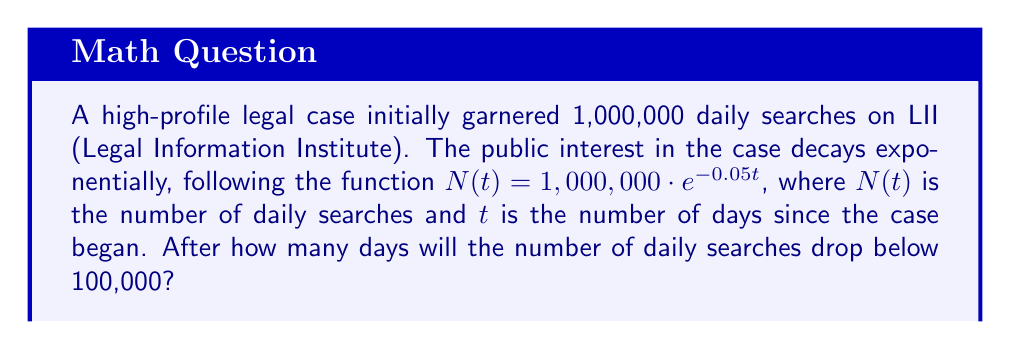Teach me how to tackle this problem. To solve this problem, we need to use the properties of logarithms. Let's approach this step-by-step:

1) We're given the function $N(t) = 1,000,000 \cdot e^{-0.05t}$

2) We want to find $t$ when $N(t) < 100,000$

3) Let's set up the equation:
   $100,000 = 1,000,000 \cdot e^{-0.05t}$

4) Divide both sides by 1,000,000:
   $0.1 = e^{-0.05t}$

5) Now, let's take the natural logarithm of both sides:
   $\ln(0.1) = \ln(e^{-0.05t})$

6) Using the property of logarithms that $\ln(e^x) = x$:
   $\ln(0.1) = -0.05t$

7) Solve for $t$:
   $t = \frac{\ln(0.1)}{-0.05}$

8) Calculate:
   $t = \frac{-2.30259}{-0.05} \approx 46.05$ days

9) Since we're looking for the number of days when searches drop below 100,000, we need to round up to the next whole day.

Therefore, it will take 47 days for the number of daily searches to drop below 100,000.
Answer: 47 days 